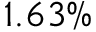<formula> <loc_0><loc_0><loc_500><loc_500>1 . 6 3 \%</formula> 